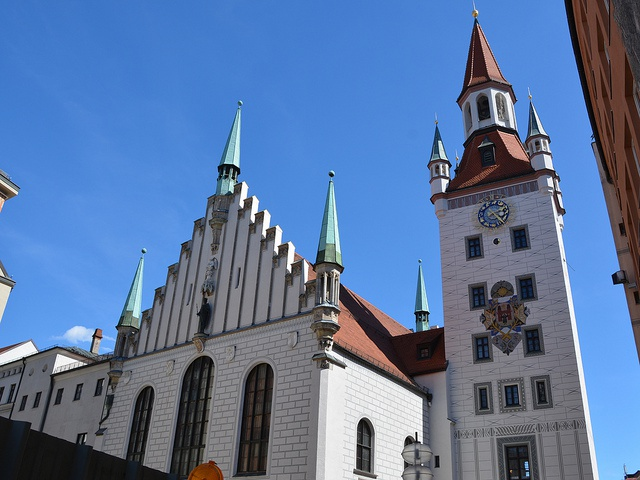Describe the objects in this image and their specific colors. I can see a clock in gray, navy, and black tones in this image. 